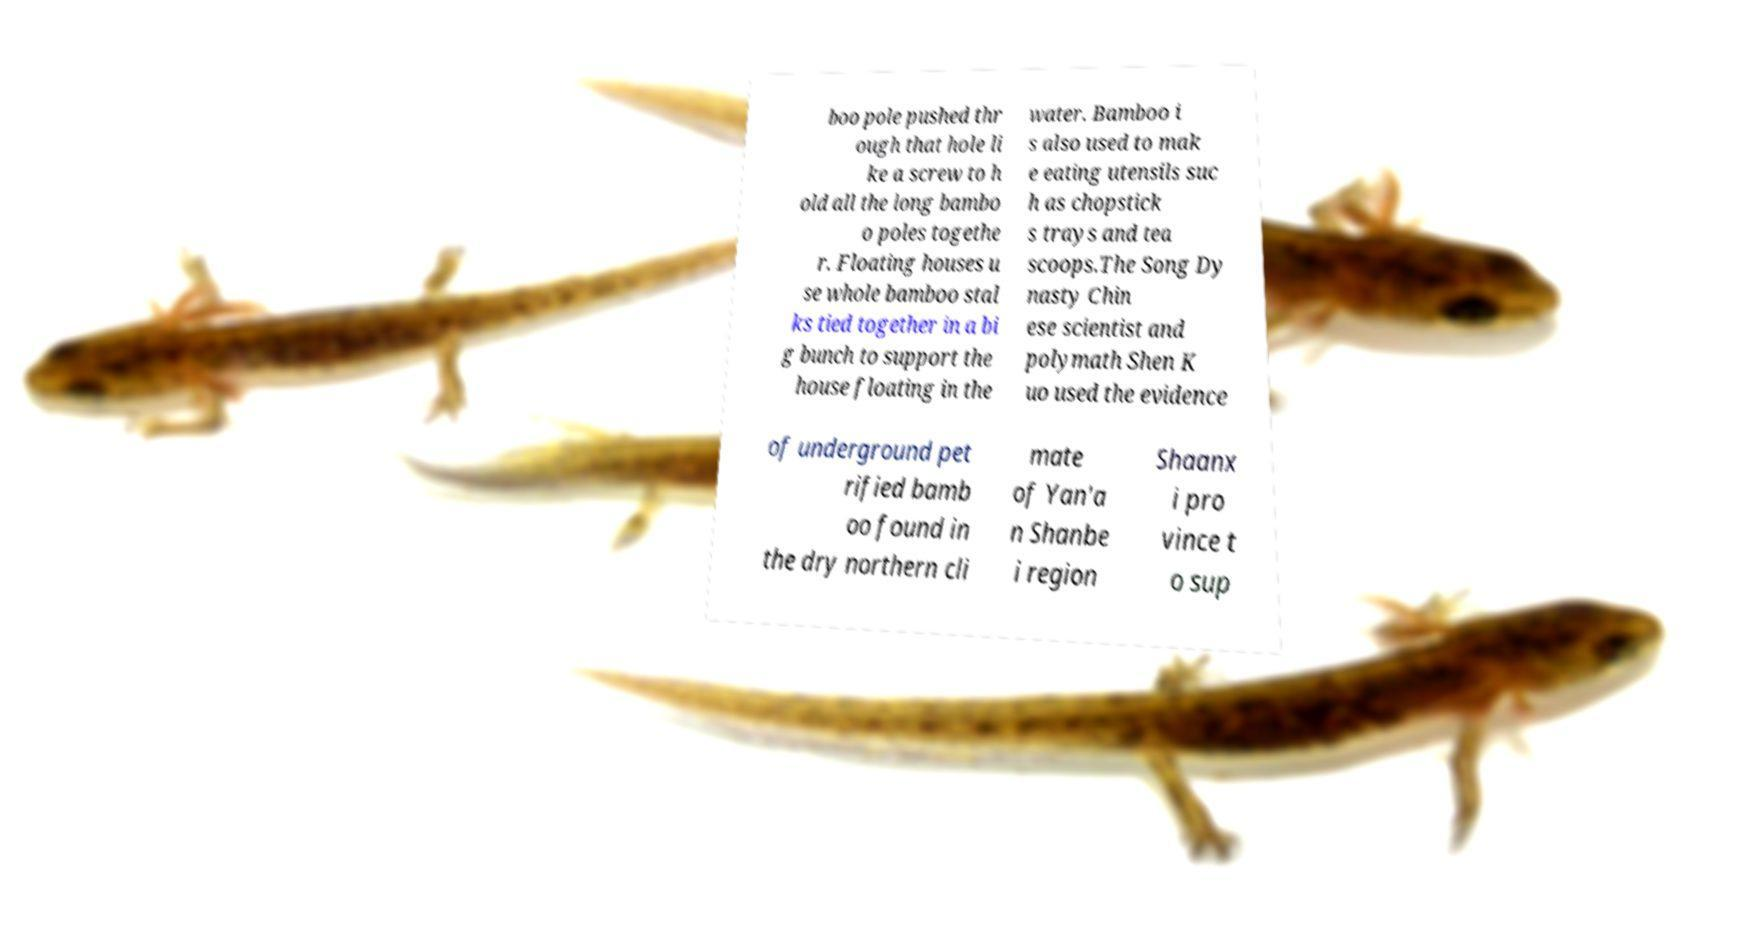For documentation purposes, I need the text within this image transcribed. Could you provide that? boo pole pushed thr ough that hole li ke a screw to h old all the long bambo o poles togethe r. Floating houses u se whole bamboo stal ks tied together in a bi g bunch to support the house floating in the water. Bamboo i s also used to mak e eating utensils suc h as chopstick s trays and tea scoops.The Song Dy nasty Chin ese scientist and polymath Shen K uo used the evidence of underground pet rified bamb oo found in the dry northern cli mate of Yan'a n Shanbe i region Shaanx i pro vince t o sup 